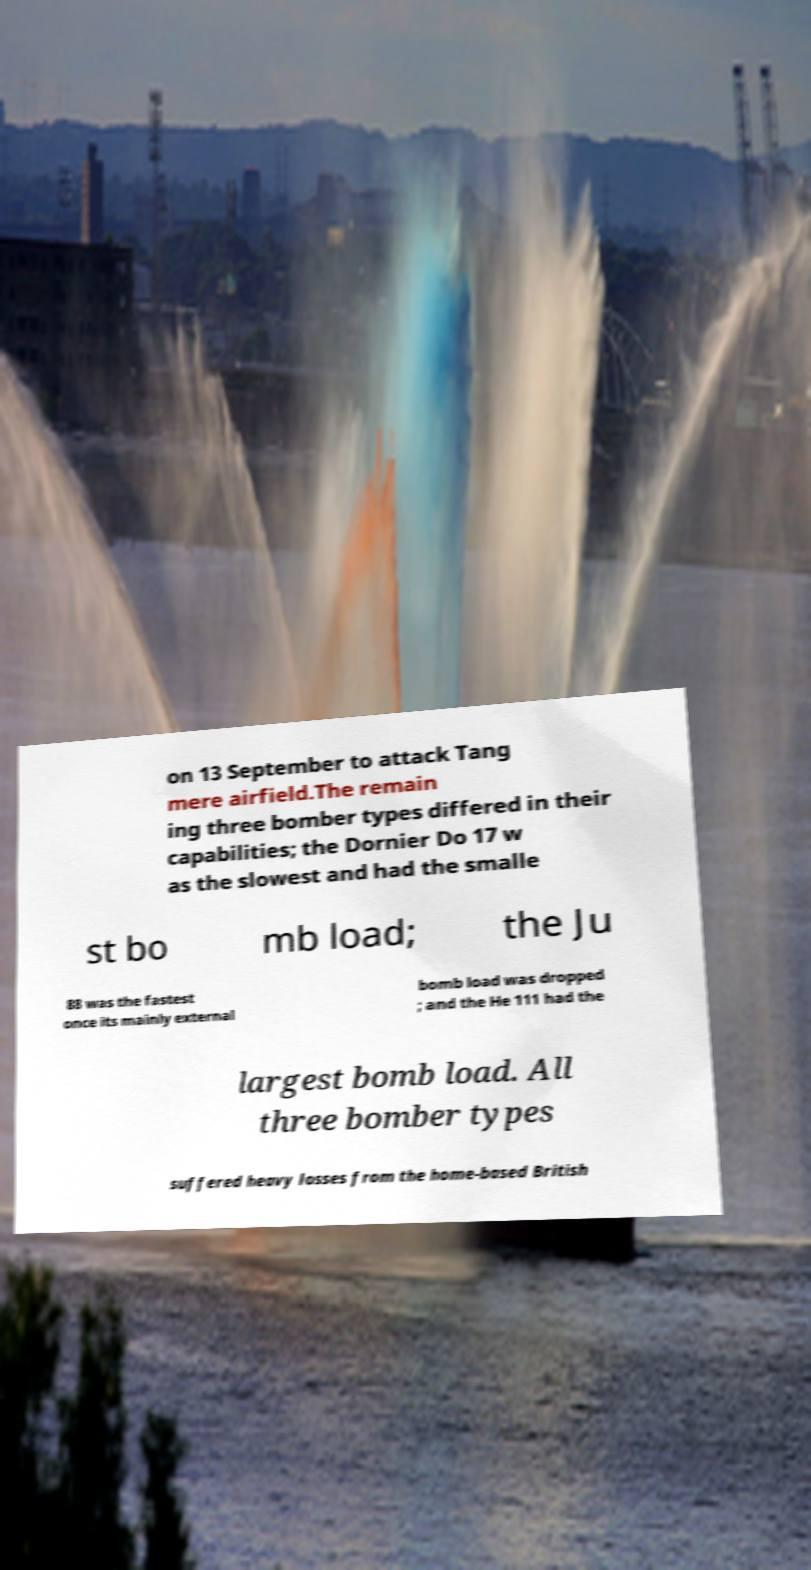Could you assist in decoding the text presented in this image and type it out clearly? on 13 September to attack Tang mere airfield.The remain ing three bomber types differed in their capabilities; the Dornier Do 17 w as the slowest and had the smalle st bo mb load; the Ju 88 was the fastest once its mainly external bomb load was dropped ; and the He 111 had the largest bomb load. All three bomber types suffered heavy losses from the home-based British 